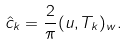Convert formula to latex. <formula><loc_0><loc_0><loc_500><loc_500>\hat { c } _ { k } = \frac { 2 } { \pi } ( u , T _ { k } ) _ { w } .</formula> 